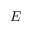Convert formula to latex. <formula><loc_0><loc_0><loc_500><loc_500>E</formula> 